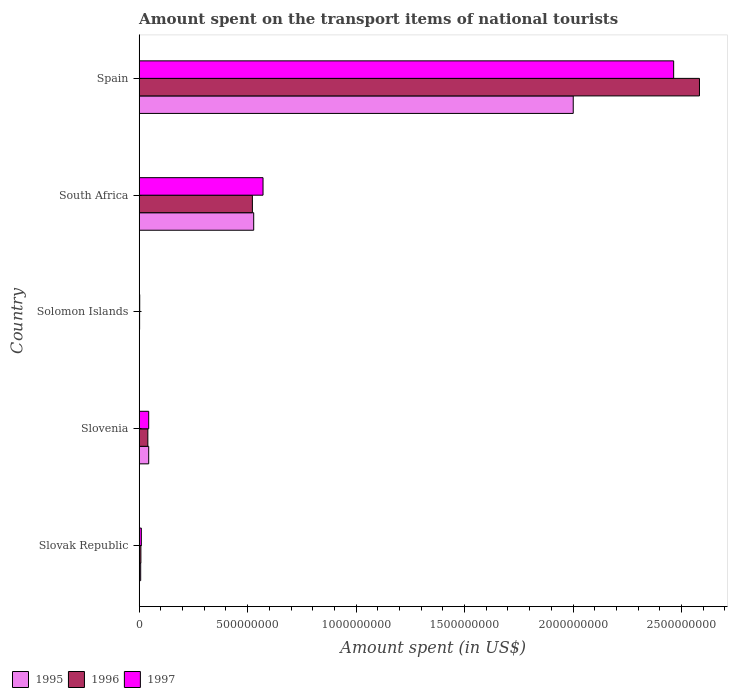How many different coloured bars are there?
Offer a very short reply. 3. How many groups of bars are there?
Ensure brevity in your answer.  5. Are the number of bars per tick equal to the number of legend labels?
Ensure brevity in your answer.  Yes. Are the number of bars on each tick of the Y-axis equal?
Give a very brief answer. Yes. How many bars are there on the 2nd tick from the top?
Your response must be concise. 3. How many bars are there on the 2nd tick from the bottom?
Ensure brevity in your answer.  3. What is the label of the 3rd group of bars from the top?
Offer a very short reply. Solomon Islands. In how many cases, is the number of bars for a given country not equal to the number of legend labels?
Give a very brief answer. 0. What is the amount spent on the transport items of national tourists in 1996 in Slovak Republic?
Keep it short and to the point. 8.00e+06. Across all countries, what is the maximum amount spent on the transport items of national tourists in 1996?
Your answer should be very brief. 2.58e+09. Across all countries, what is the minimum amount spent on the transport items of national tourists in 1996?
Make the answer very short. 2.10e+06. In which country was the amount spent on the transport items of national tourists in 1997 minimum?
Give a very brief answer. Solomon Islands. What is the total amount spent on the transport items of national tourists in 1997 in the graph?
Ensure brevity in your answer.  3.09e+09. What is the difference between the amount spent on the transport items of national tourists in 1997 in Slovenia and that in Spain?
Your answer should be very brief. -2.42e+09. What is the difference between the amount spent on the transport items of national tourists in 1997 in Slovak Republic and the amount spent on the transport items of national tourists in 1995 in Slovenia?
Provide a succinct answer. -3.40e+07. What is the average amount spent on the transport items of national tourists in 1996 per country?
Make the answer very short. 6.31e+08. What is the difference between the amount spent on the transport items of national tourists in 1996 and amount spent on the transport items of national tourists in 1997 in South Africa?
Provide a succinct answer. -4.90e+07. In how many countries, is the amount spent on the transport items of national tourists in 1995 greater than 2600000000 US$?
Offer a terse response. 0. What is the ratio of the amount spent on the transport items of national tourists in 1996 in Slovak Republic to that in Solomon Islands?
Your response must be concise. 3.81. Is the difference between the amount spent on the transport items of national tourists in 1996 in Slovenia and South Africa greater than the difference between the amount spent on the transport items of national tourists in 1997 in Slovenia and South Africa?
Your response must be concise. Yes. What is the difference between the highest and the second highest amount spent on the transport items of national tourists in 1995?
Make the answer very short. 1.47e+09. What is the difference between the highest and the lowest amount spent on the transport items of national tourists in 1997?
Offer a very short reply. 2.46e+09. What does the 3rd bar from the top in Solomon Islands represents?
Your answer should be very brief. 1995. What does the 1st bar from the bottom in Spain represents?
Your answer should be compact. 1995. How many bars are there?
Your answer should be compact. 15. How many countries are there in the graph?
Provide a short and direct response. 5. What is the difference between two consecutive major ticks on the X-axis?
Make the answer very short. 5.00e+08. Are the values on the major ticks of X-axis written in scientific E-notation?
Ensure brevity in your answer.  No. Where does the legend appear in the graph?
Your answer should be very brief. Bottom left. What is the title of the graph?
Your answer should be very brief. Amount spent on the transport items of national tourists. Does "1967" appear as one of the legend labels in the graph?
Provide a succinct answer. No. What is the label or title of the X-axis?
Ensure brevity in your answer.  Amount spent (in US$). What is the Amount spent (in US$) in 1995 in Slovak Republic?
Provide a short and direct response. 7.00e+06. What is the Amount spent (in US$) of 1995 in Slovenia?
Provide a short and direct response. 4.40e+07. What is the Amount spent (in US$) of 1996 in Slovenia?
Provide a short and direct response. 4.00e+07. What is the Amount spent (in US$) in 1997 in Slovenia?
Your answer should be compact. 4.40e+07. What is the Amount spent (in US$) of 1995 in Solomon Islands?
Offer a terse response. 1.40e+06. What is the Amount spent (in US$) of 1996 in Solomon Islands?
Your answer should be very brief. 2.10e+06. What is the Amount spent (in US$) in 1997 in Solomon Islands?
Make the answer very short. 2.60e+06. What is the Amount spent (in US$) of 1995 in South Africa?
Provide a succinct answer. 5.28e+08. What is the Amount spent (in US$) in 1996 in South Africa?
Offer a very short reply. 5.22e+08. What is the Amount spent (in US$) in 1997 in South Africa?
Make the answer very short. 5.71e+08. What is the Amount spent (in US$) of 1995 in Spain?
Give a very brief answer. 2.00e+09. What is the Amount spent (in US$) of 1996 in Spain?
Provide a succinct answer. 2.58e+09. What is the Amount spent (in US$) in 1997 in Spain?
Provide a succinct answer. 2.46e+09. Across all countries, what is the maximum Amount spent (in US$) in 1995?
Give a very brief answer. 2.00e+09. Across all countries, what is the maximum Amount spent (in US$) of 1996?
Your response must be concise. 2.58e+09. Across all countries, what is the maximum Amount spent (in US$) of 1997?
Ensure brevity in your answer.  2.46e+09. Across all countries, what is the minimum Amount spent (in US$) in 1995?
Give a very brief answer. 1.40e+06. Across all countries, what is the minimum Amount spent (in US$) in 1996?
Give a very brief answer. 2.10e+06. Across all countries, what is the minimum Amount spent (in US$) of 1997?
Make the answer very short. 2.60e+06. What is the total Amount spent (in US$) of 1995 in the graph?
Offer a very short reply. 2.58e+09. What is the total Amount spent (in US$) in 1996 in the graph?
Keep it short and to the point. 3.16e+09. What is the total Amount spent (in US$) of 1997 in the graph?
Your answer should be very brief. 3.09e+09. What is the difference between the Amount spent (in US$) in 1995 in Slovak Republic and that in Slovenia?
Provide a short and direct response. -3.70e+07. What is the difference between the Amount spent (in US$) in 1996 in Slovak Republic and that in Slovenia?
Offer a terse response. -3.20e+07. What is the difference between the Amount spent (in US$) of 1997 in Slovak Republic and that in Slovenia?
Give a very brief answer. -3.40e+07. What is the difference between the Amount spent (in US$) in 1995 in Slovak Republic and that in Solomon Islands?
Provide a short and direct response. 5.60e+06. What is the difference between the Amount spent (in US$) in 1996 in Slovak Republic and that in Solomon Islands?
Provide a short and direct response. 5.90e+06. What is the difference between the Amount spent (in US$) in 1997 in Slovak Republic and that in Solomon Islands?
Offer a very short reply. 7.40e+06. What is the difference between the Amount spent (in US$) in 1995 in Slovak Republic and that in South Africa?
Ensure brevity in your answer.  -5.21e+08. What is the difference between the Amount spent (in US$) of 1996 in Slovak Republic and that in South Africa?
Make the answer very short. -5.14e+08. What is the difference between the Amount spent (in US$) in 1997 in Slovak Republic and that in South Africa?
Ensure brevity in your answer.  -5.61e+08. What is the difference between the Amount spent (in US$) of 1995 in Slovak Republic and that in Spain?
Make the answer very short. -1.99e+09. What is the difference between the Amount spent (in US$) of 1996 in Slovak Republic and that in Spain?
Ensure brevity in your answer.  -2.58e+09. What is the difference between the Amount spent (in US$) of 1997 in Slovak Republic and that in Spain?
Your answer should be compact. -2.45e+09. What is the difference between the Amount spent (in US$) in 1995 in Slovenia and that in Solomon Islands?
Provide a succinct answer. 4.26e+07. What is the difference between the Amount spent (in US$) of 1996 in Slovenia and that in Solomon Islands?
Ensure brevity in your answer.  3.79e+07. What is the difference between the Amount spent (in US$) of 1997 in Slovenia and that in Solomon Islands?
Provide a short and direct response. 4.14e+07. What is the difference between the Amount spent (in US$) in 1995 in Slovenia and that in South Africa?
Your answer should be very brief. -4.84e+08. What is the difference between the Amount spent (in US$) in 1996 in Slovenia and that in South Africa?
Your answer should be compact. -4.82e+08. What is the difference between the Amount spent (in US$) in 1997 in Slovenia and that in South Africa?
Make the answer very short. -5.27e+08. What is the difference between the Amount spent (in US$) of 1995 in Slovenia and that in Spain?
Your answer should be compact. -1.96e+09. What is the difference between the Amount spent (in US$) in 1996 in Slovenia and that in Spain?
Give a very brief answer. -2.54e+09. What is the difference between the Amount spent (in US$) in 1997 in Slovenia and that in Spain?
Provide a succinct answer. -2.42e+09. What is the difference between the Amount spent (in US$) of 1995 in Solomon Islands and that in South Africa?
Your answer should be compact. -5.27e+08. What is the difference between the Amount spent (in US$) of 1996 in Solomon Islands and that in South Africa?
Offer a terse response. -5.20e+08. What is the difference between the Amount spent (in US$) of 1997 in Solomon Islands and that in South Africa?
Your response must be concise. -5.68e+08. What is the difference between the Amount spent (in US$) of 1995 in Solomon Islands and that in Spain?
Provide a succinct answer. -2.00e+09. What is the difference between the Amount spent (in US$) in 1996 in Solomon Islands and that in Spain?
Your answer should be very brief. -2.58e+09. What is the difference between the Amount spent (in US$) in 1997 in Solomon Islands and that in Spain?
Your answer should be very brief. -2.46e+09. What is the difference between the Amount spent (in US$) in 1995 in South Africa and that in Spain?
Ensure brevity in your answer.  -1.47e+09. What is the difference between the Amount spent (in US$) in 1996 in South Africa and that in Spain?
Offer a very short reply. -2.06e+09. What is the difference between the Amount spent (in US$) of 1997 in South Africa and that in Spain?
Offer a very short reply. -1.89e+09. What is the difference between the Amount spent (in US$) of 1995 in Slovak Republic and the Amount spent (in US$) of 1996 in Slovenia?
Make the answer very short. -3.30e+07. What is the difference between the Amount spent (in US$) of 1995 in Slovak Republic and the Amount spent (in US$) of 1997 in Slovenia?
Provide a short and direct response. -3.70e+07. What is the difference between the Amount spent (in US$) in 1996 in Slovak Republic and the Amount spent (in US$) in 1997 in Slovenia?
Offer a very short reply. -3.60e+07. What is the difference between the Amount spent (in US$) of 1995 in Slovak Republic and the Amount spent (in US$) of 1996 in Solomon Islands?
Offer a very short reply. 4.90e+06. What is the difference between the Amount spent (in US$) of 1995 in Slovak Republic and the Amount spent (in US$) of 1997 in Solomon Islands?
Offer a terse response. 4.40e+06. What is the difference between the Amount spent (in US$) of 1996 in Slovak Republic and the Amount spent (in US$) of 1997 in Solomon Islands?
Provide a succinct answer. 5.40e+06. What is the difference between the Amount spent (in US$) of 1995 in Slovak Republic and the Amount spent (in US$) of 1996 in South Africa?
Provide a short and direct response. -5.15e+08. What is the difference between the Amount spent (in US$) in 1995 in Slovak Republic and the Amount spent (in US$) in 1997 in South Africa?
Give a very brief answer. -5.64e+08. What is the difference between the Amount spent (in US$) in 1996 in Slovak Republic and the Amount spent (in US$) in 1997 in South Africa?
Make the answer very short. -5.63e+08. What is the difference between the Amount spent (in US$) in 1995 in Slovak Republic and the Amount spent (in US$) in 1996 in Spain?
Offer a terse response. -2.58e+09. What is the difference between the Amount spent (in US$) in 1995 in Slovak Republic and the Amount spent (in US$) in 1997 in Spain?
Your answer should be very brief. -2.46e+09. What is the difference between the Amount spent (in US$) in 1996 in Slovak Republic and the Amount spent (in US$) in 1997 in Spain?
Your answer should be very brief. -2.46e+09. What is the difference between the Amount spent (in US$) of 1995 in Slovenia and the Amount spent (in US$) of 1996 in Solomon Islands?
Your answer should be compact. 4.19e+07. What is the difference between the Amount spent (in US$) of 1995 in Slovenia and the Amount spent (in US$) of 1997 in Solomon Islands?
Offer a terse response. 4.14e+07. What is the difference between the Amount spent (in US$) in 1996 in Slovenia and the Amount spent (in US$) in 1997 in Solomon Islands?
Offer a terse response. 3.74e+07. What is the difference between the Amount spent (in US$) in 1995 in Slovenia and the Amount spent (in US$) in 1996 in South Africa?
Your response must be concise. -4.78e+08. What is the difference between the Amount spent (in US$) in 1995 in Slovenia and the Amount spent (in US$) in 1997 in South Africa?
Your answer should be very brief. -5.27e+08. What is the difference between the Amount spent (in US$) in 1996 in Slovenia and the Amount spent (in US$) in 1997 in South Africa?
Ensure brevity in your answer.  -5.31e+08. What is the difference between the Amount spent (in US$) in 1995 in Slovenia and the Amount spent (in US$) in 1996 in Spain?
Your response must be concise. -2.54e+09. What is the difference between the Amount spent (in US$) of 1995 in Slovenia and the Amount spent (in US$) of 1997 in Spain?
Your answer should be very brief. -2.42e+09. What is the difference between the Amount spent (in US$) in 1996 in Slovenia and the Amount spent (in US$) in 1997 in Spain?
Offer a very short reply. -2.42e+09. What is the difference between the Amount spent (in US$) of 1995 in Solomon Islands and the Amount spent (in US$) of 1996 in South Africa?
Make the answer very short. -5.21e+08. What is the difference between the Amount spent (in US$) in 1995 in Solomon Islands and the Amount spent (in US$) in 1997 in South Africa?
Offer a very short reply. -5.70e+08. What is the difference between the Amount spent (in US$) of 1996 in Solomon Islands and the Amount spent (in US$) of 1997 in South Africa?
Your answer should be very brief. -5.69e+08. What is the difference between the Amount spent (in US$) in 1995 in Solomon Islands and the Amount spent (in US$) in 1996 in Spain?
Offer a terse response. -2.58e+09. What is the difference between the Amount spent (in US$) in 1995 in Solomon Islands and the Amount spent (in US$) in 1997 in Spain?
Make the answer very short. -2.46e+09. What is the difference between the Amount spent (in US$) of 1996 in Solomon Islands and the Amount spent (in US$) of 1997 in Spain?
Your answer should be compact. -2.46e+09. What is the difference between the Amount spent (in US$) in 1995 in South Africa and the Amount spent (in US$) in 1996 in Spain?
Provide a succinct answer. -2.06e+09. What is the difference between the Amount spent (in US$) in 1995 in South Africa and the Amount spent (in US$) in 1997 in Spain?
Give a very brief answer. -1.94e+09. What is the difference between the Amount spent (in US$) of 1996 in South Africa and the Amount spent (in US$) of 1997 in Spain?
Provide a succinct answer. -1.94e+09. What is the average Amount spent (in US$) of 1995 per country?
Give a very brief answer. 5.16e+08. What is the average Amount spent (in US$) in 1996 per country?
Give a very brief answer. 6.31e+08. What is the average Amount spent (in US$) in 1997 per country?
Your response must be concise. 6.18e+08. What is the difference between the Amount spent (in US$) in 1995 and Amount spent (in US$) in 1996 in Slovak Republic?
Your answer should be compact. -1.00e+06. What is the difference between the Amount spent (in US$) in 1995 and Amount spent (in US$) in 1997 in Slovak Republic?
Your answer should be very brief. -3.00e+06. What is the difference between the Amount spent (in US$) in 1995 and Amount spent (in US$) in 1996 in Slovenia?
Keep it short and to the point. 4.00e+06. What is the difference between the Amount spent (in US$) in 1995 and Amount spent (in US$) in 1997 in Slovenia?
Give a very brief answer. 0. What is the difference between the Amount spent (in US$) in 1995 and Amount spent (in US$) in 1996 in Solomon Islands?
Provide a short and direct response. -7.00e+05. What is the difference between the Amount spent (in US$) in 1995 and Amount spent (in US$) in 1997 in Solomon Islands?
Provide a short and direct response. -1.20e+06. What is the difference between the Amount spent (in US$) of 1996 and Amount spent (in US$) of 1997 in Solomon Islands?
Offer a terse response. -5.00e+05. What is the difference between the Amount spent (in US$) in 1995 and Amount spent (in US$) in 1997 in South Africa?
Make the answer very short. -4.30e+07. What is the difference between the Amount spent (in US$) of 1996 and Amount spent (in US$) of 1997 in South Africa?
Offer a very short reply. -4.90e+07. What is the difference between the Amount spent (in US$) in 1995 and Amount spent (in US$) in 1996 in Spain?
Give a very brief answer. -5.82e+08. What is the difference between the Amount spent (in US$) of 1995 and Amount spent (in US$) of 1997 in Spain?
Provide a short and direct response. -4.63e+08. What is the difference between the Amount spent (in US$) in 1996 and Amount spent (in US$) in 1997 in Spain?
Provide a short and direct response. 1.19e+08. What is the ratio of the Amount spent (in US$) in 1995 in Slovak Republic to that in Slovenia?
Your answer should be very brief. 0.16. What is the ratio of the Amount spent (in US$) of 1997 in Slovak Republic to that in Slovenia?
Provide a short and direct response. 0.23. What is the ratio of the Amount spent (in US$) in 1995 in Slovak Republic to that in Solomon Islands?
Your answer should be very brief. 5. What is the ratio of the Amount spent (in US$) in 1996 in Slovak Republic to that in Solomon Islands?
Your response must be concise. 3.81. What is the ratio of the Amount spent (in US$) in 1997 in Slovak Republic to that in Solomon Islands?
Keep it short and to the point. 3.85. What is the ratio of the Amount spent (in US$) of 1995 in Slovak Republic to that in South Africa?
Offer a very short reply. 0.01. What is the ratio of the Amount spent (in US$) of 1996 in Slovak Republic to that in South Africa?
Offer a terse response. 0.02. What is the ratio of the Amount spent (in US$) of 1997 in Slovak Republic to that in South Africa?
Your answer should be compact. 0.02. What is the ratio of the Amount spent (in US$) of 1995 in Slovak Republic to that in Spain?
Offer a terse response. 0. What is the ratio of the Amount spent (in US$) of 1996 in Slovak Republic to that in Spain?
Your answer should be compact. 0. What is the ratio of the Amount spent (in US$) in 1997 in Slovak Republic to that in Spain?
Offer a very short reply. 0. What is the ratio of the Amount spent (in US$) in 1995 in Slovenia to that in Solomon Islands?
Provide a succinct answer. 31.43. What is the ratio of the Amount spent (in US$) of 1996 in Slovenia to that in Solomon Islands?
Offer a very short reply. 19.05. What is the ratio of the Amount spent (in US$) of 1997 in Slovenia to that in Solomon Islands?
Provide a succinct answer. 16.92. What is the ratio of the Amount spent (in US$) of 1995 in Slovenia to that in South Africa?
Your answer should be very brief. 0.08. What is the ratio of the Amount spent (in US$) of 1996 in Slovenia to that in South Africa?
Offer a terse response. 0.08. What is the ratio of the Amount spent (in US$) of 1997 in Slovenia to that in South Africa?
Give a very brief answer. 0.08. What is the ratio of the Amount spent (in US$) in 1995 in Slovenia to that in Spain?
Ensure brevity in your answer.  0.02. What is the ratio of the Amount spent (in US$) of 1996 in Slovenia to that in Spain?
Ensure brevity in your answer.  0.02. What is the ratio of the Amount spent (in US$) in 1997 in Slovenia to that in Spain?
Make the answer very short. 0.02. What is the ratio of the Amount spent (in US$) in 1995 in Solomon Islands to that in South Africa?
Give a very brief answer. 0. What is the ratio of the Amount spent (in US$) in 1996 in Solomon Islands to that in South Africa?
Make the answer very short. 0. What is the ratio of the Amount spent (in US$) in 1997 in Solomon Islands to that in South Africa?
Your answer should be compact. 0. What is the ratio of the Amount spent (in US$) in 1995 in Solomon Islands to that in Spain?
Your answer should be very brief. 0. What is the ratio of the Amount spent (in US$) in 1996 in Solomon Islands to that in Spain?
Ensure brevity in your answer.  0. What is the ratio of the Amount spent (in US$) of 1997 in Solomon Islands to that in Spain?
Offer a terse response. 0. What is the ratio of the Amount spent (in US$) of 1995 in South Africa to that in Spain?
Give a very brief answer. 0.26. What is the ratio of the Amount spent (in US$) in 1996 in South Africa to that in Spain?
Ensure brevity in your answer.  0.2. What is the ratio of the Amount spent (in US$) in 1997 in South Africa to that in Spain?
Offer a terse response. 0.23. What is the difference between the highest and the second highest Amount spent (in US$) in 1995?
Your answer should be compact. 1.47e+09. What is the difference between the highest and the second highest Amount spent (in US$) in 1996?
Provide a succinct answer. 2.06e+09. What is the difference between the highest and the second highest Amount spent (in US$) in 1997?
Your answer should be compact. 1.89e+09. What is the difference between the highest and the lowest Amount spent (in US$) of 1995?
Your response must be concise. 2.00e+09. What is the difference between the highest and the lowest Amount spent (in US$) of 1996?
Offer a very short reply. 2.58e+09. What is the difference between the highest and the lowest Amount spent (in US$) in 1997?
Your response must be concise. 2.46e+09. 